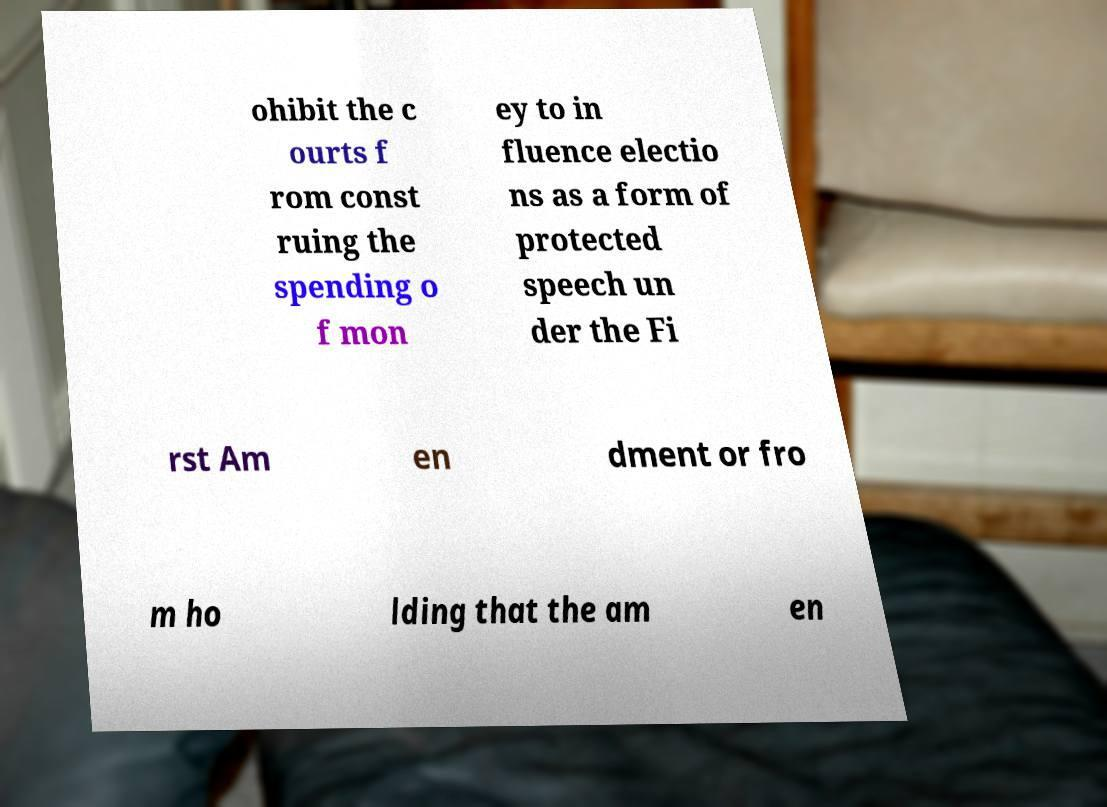Could you assist in decoding the text presented in this image and type it out clearly? ohibit the c ourts f rom const ruing the spending o f mon ey to in fluence electio ns as a form of protected speech un der the Fi rst Am en dment or fro m ho lding that the am en 